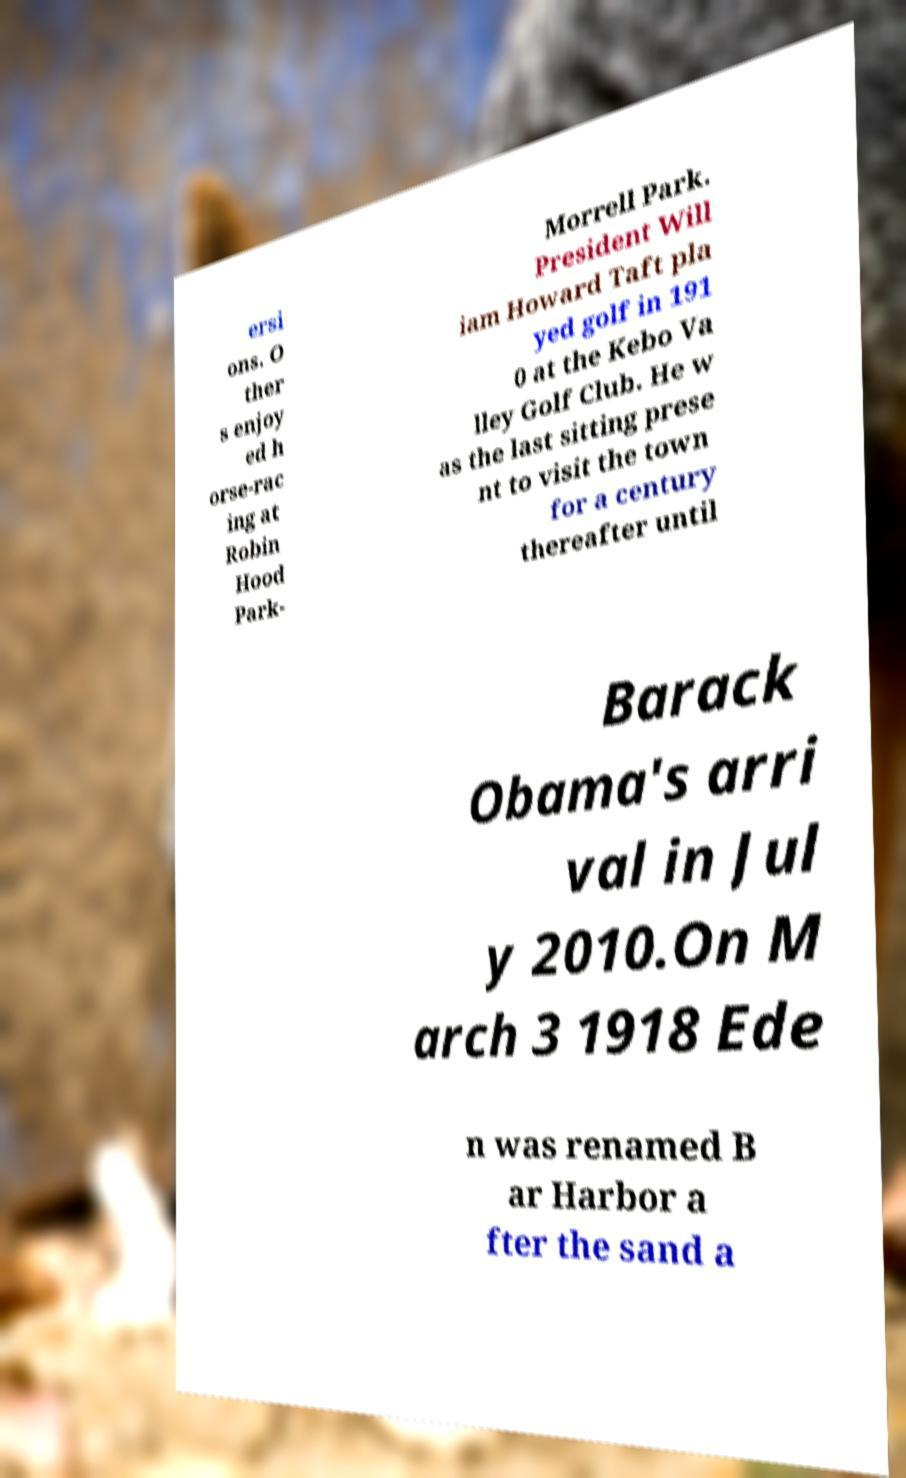I need the written content from this picture converted into text. Can you do that? ersi ons. O ther s enjoy ed h orse-rac ing at Robin Hood Park- Morrell Park. President Will iam Howard Taft pla yed golf in 191 0 at the Kebo Va lley Golf Club. He w as the last sitting prese nt to visit the town for a century thereafter until Barack Obama's arri val in Jul y 2010.On M arch 3 1918 Ede n was renamed B ar Harbor a fter the sand a 